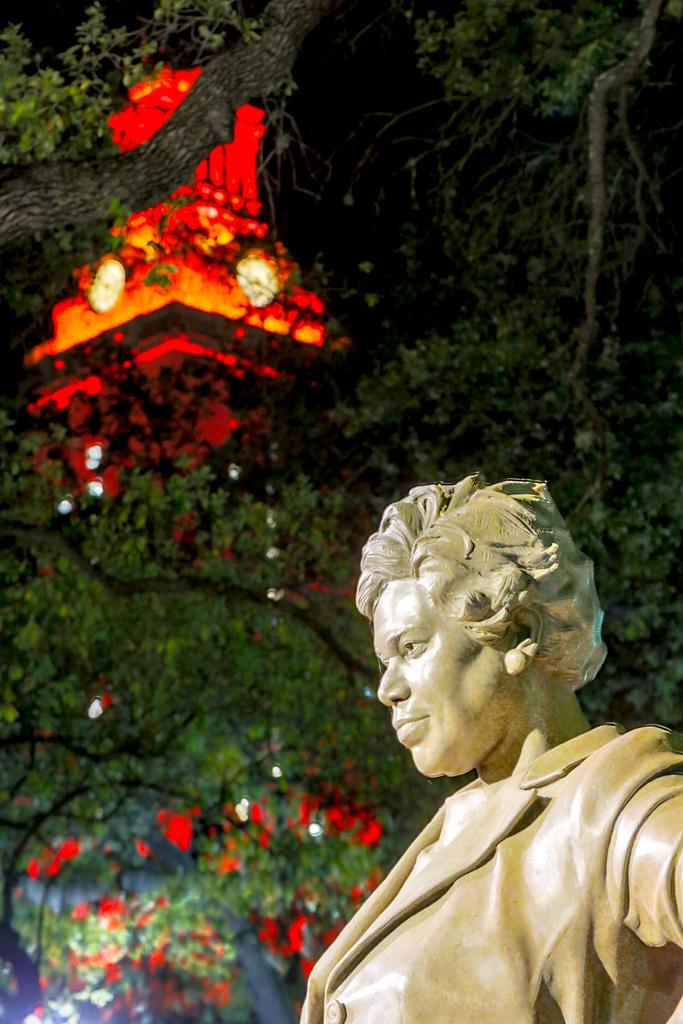What is located on the right side of the image? There is a statue on the right side of the image. What can be seen in the background of the image? There are trees, lights, and a clock tower in the background of the image. What is visible at the top of the image? The sky is visible at the top of the image. What type of operation is being performed on the desk in the image? There is no desk present in the image, and therefore no operation is being performed. Can you describe the skateboarding activity taking place in the image? There is no skateboarding activity present in the image. 